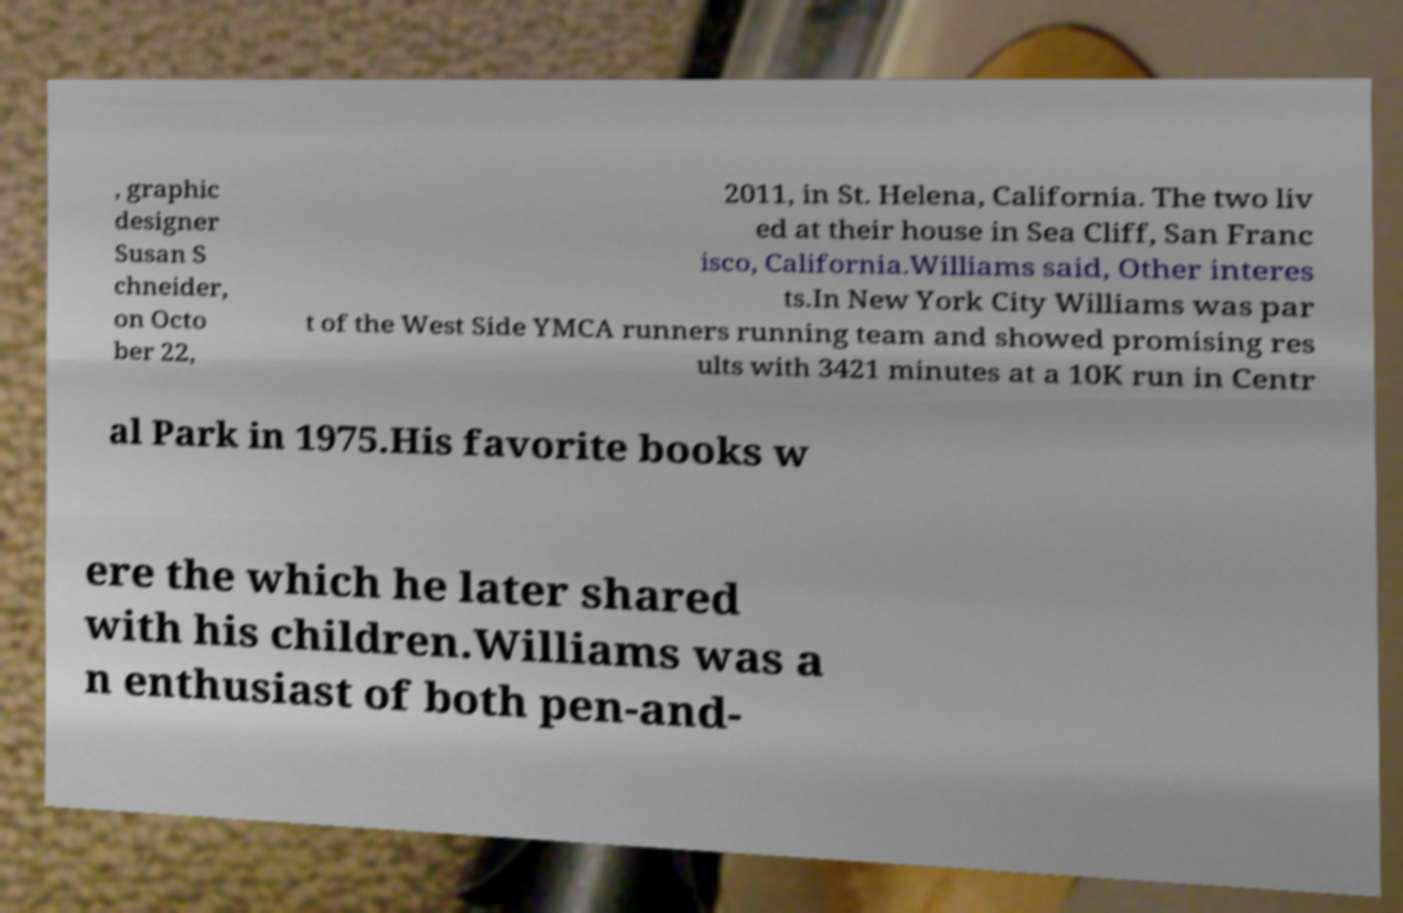I need the written content from this picture converted into text. Can you do that? , graphic designer Susan S chneider, on Octo ber 22, 2011, in St. Helena, California. The two liv ed at their house in Sea Cliff, San Franc isco, California.Williams said, Other interes ts.In New York City Williams was par t of the West Side YMCA runners running team and showed promising res ults with 3421 minutes at a 10K run in Centr al Park in 1975.His favorite books w ere the which he later shared with his children.Williams was a n enthusiast of both pen-and- 